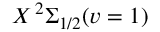Convert formula to latex. <formula><loc_0><loc_0><loc_500><loc_500>X \, ^ { 2 } \Sigma _ { 1 / 2 } ( v = 1 )</formula> 